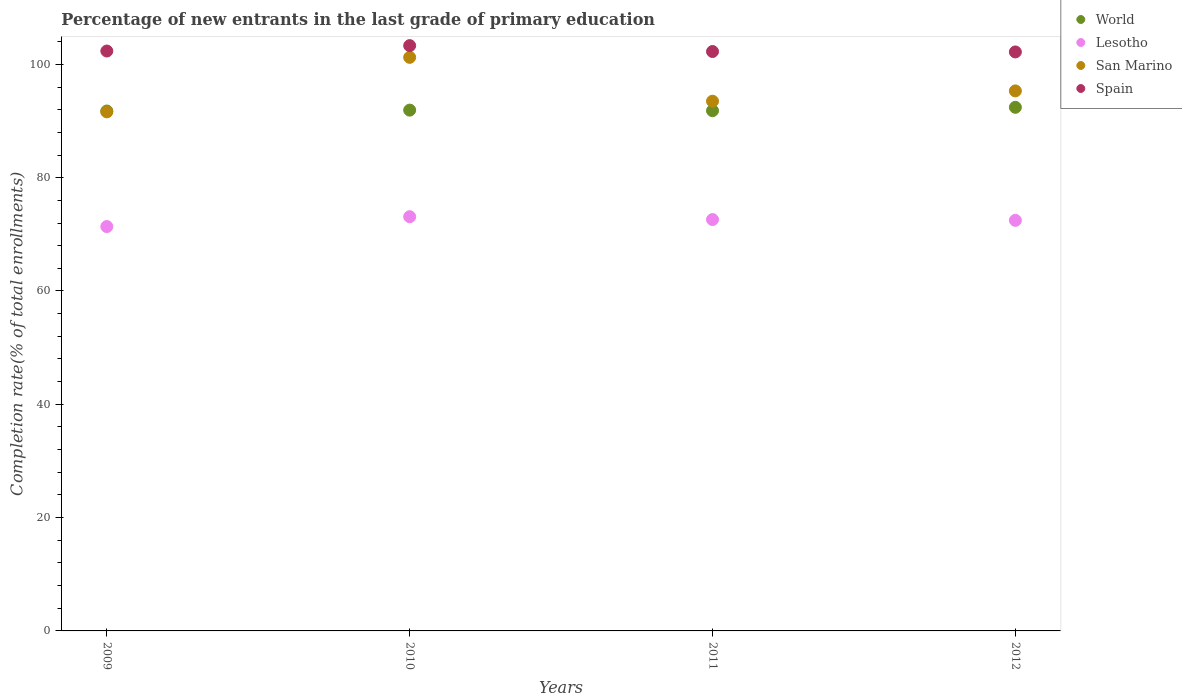Is the number of dotlines equal to the number of legend labels?
Offer a terse response. Yes. What is the percentage of new entrants in Spain in 2009?
Give a very brief answer. 102.36. Across all years, what is the maximum percentage of new entrants in World?
Offer a terse response. 92.42. Across all years, what is the minimum percentage of new entrants in Spain?
Your answer should be compact. 102.19. In which year was the percentage of new entrants in Lesotho minimum?
Make the answer very short. 2009. What is the total percentage of new entrants in Spain in the graph?
Give a very brief answer. 410.13. What is the difference between the percentage of new entrants in World in 2010 and that in 2011?
Your response must be concise. 0.1. What is the difference between the percentage of new entrants in Spain in 2012 and the percentage of new entrants in San Marino in 2009?
Offer a terse response. 10.58. What is the average percentage of new entrants in San Marino per year?
Give a very brief answer. 95.42. In the year 2011, what is the difference between the percentage of new entrants in San Marino and percentage of new entrants in World?
Keep it short and to the point. 1.67. What is the ratio of the percentage of new entrants in World in 2011 to that in 2012?
Make the answer very short. 0.99. What is the difference between the highest and the second highest percentage of new entrants in Spain?
Offer a terse response. 0.95. What is the difference between the highest and the lowest percentage of new entrants in Lesotho?
Offer a terse response. 1.74. Is the percentage of new entrants in Spain strictly greater than the percentage of new entrants in San Marino over the years?
Your response must be concise. Yes. Is the percentage of new entrants in World strictly less than the percentage of new entrants in Spain over the years?
Make the answer very short. Yes. Are the values on the major ticks of Y-axis written in scientific E-notation?
Offer a very short reply. No. Where does the legend appear in the graph?
Your answer should be compact. Top right. How many legend labels are there?
Give a very brief answer. 4. How are the legend labels stacked?
Provide a succinct answer. Vertical. What is the title of the graph?
Your answer should be very brief. Percentage of new entrants in the last grade of primary education. Does "Cameroon" appear as one of the legend labels in the graph?
Provide a succinct answer. No. What is the label or title of the X-axis?
Offer a very short reply. Years. What is the label or title of the Y-axis?
Your response must be concise. Completion rate(% of total enrollments). What is the Completion rate(% of total enrollments) of World in 2009?
Provide a short and direct response. 91.77. What is the Completion rate(% of total enrollments) of Lesotho in 2009?
Your answer should be compact. 71.37. What is the Completion rate(% of total enrollments) in San Marino in 2009?
Give a very brief answer. 91.62. What is the Completion rate(% of total enrollments) in Spain in 2009?
Offer a terse response. 102.36. What is the Completion rate(% of total enrollments) of World in 2010?
Keep it short and to the point. 91.92. What is the Completion rate(% of total enrollments) in Lesotho in 2010?
Offer a terse response. 73.11. What is the Completion rate(% of total enrollments) of San Marino in 2010?
Ensure brevity in your answer.  101.24. What is the Completion rate(% of total enrollments) in Spain in 2010?
Offer a terse response. 103.31. What is the Completion rate(% of total enrollments) in World in 2011?
Ensure brevity in your answer.  91.83. What is the Completion rate(% of total enrollments) of Lesotho in 2011?
Provide a succinct answer. 72.61. What is the Completion rate(% of total enrollments) in San Marino in 2011?
Make the answer very short. 93.5. What is the Completion rate(% of total enrollments) in Spain in 2011?
Ensure brevity in your answer.  102.27. What is the Completion rate(% of total enrollments) in World in 2012?
Offer a very short reply. 92.42. What is the Completion rate(% of total enrollments) in Lesotho in 2012?
Your response must be concise. 72.47. What is the Completion rate(% of total enrollments) of San Marino in 2012?
Ensure brevity in your answer.  95.32. What is the Completion rate(% of total enrollments) of Spain in 2012?
Your answer should be compact. 102.19. Across all years, what is the maximum Completion rate(% of total enrollments) in World?
Provide a short and direct response. 92.42. Across all years, what is the maximum Completion rate(% of total enrollments) in Lesotho?
Make the answer very short. 73.11. Across all years, what is the maximum Completion rate(% of total enrollments) of San Marino?
Your response must be concise. 101.24. Across all years, what is the maximum Completion rate(% of total enrollments) of Spain?
Make the answer very short. 103.31. Across all years, what is the minimum Completion rate(% of total enrollments) of World?
Provide a succinct answer. 91.77. Across all years, what is the minimum Completion rate(% of total enrollments) in Lesotho?
Your answer should be compact. 71.37. Across all years, what is the minimum Completion rate(% of total enrollments) of San Marino?
Keep it short and to the point. 91.62. Across all years, what is the minimum Completion rate(% of total enrollments) of Spain?
Provide a succinct answer. 102.19. What is the total Completion rate(% of total enrollments) in World in the graph?
Make the answer very short. 367.94. What is the total Completion rate(% of total enrollments) of Lesotho in the graph?
Offer a terse response. 289.56. What is the total Completion rate(% of total enrollments) of San Marino in the graph?
Give a very brief answer. 381.67. What is the total Completion rate(% of total enrollments) of Spain in the graph?
Your answer should be compact. 410.13. What is the difference between the Completion rate(% of total enrollments) in World in 2009 and that in 2010?
Offer a terse response. -0.16. What is the difference between the Completion rate(% of total enrollments) of Lesotho in 2009 and that in 2010?
Ensure brevity in your answer.  -1.74. What is the difference between the Completion rate(% of total enrollments) of San Marino in 2009 and that in 2010?
Your answer should be compact. -9.62. What is the difference between the Completion rate(% of total enrollments) in Spain in 2009 and that in 2010?
Ensure brevity in your answer.  -0.95. What is the difference between the Completion rate(% of total enrollments) of World in 2009 and that in 2011?
Make the answer very short. -0.06. What is the difference between the Completion rate(% of total enrollments) in Lesotho in 2009 and that in 2011?
Offer a terse response. -1.24. What is the difference between the Completion rate(% of total enrollments) in San Marino in 2009 and that in 2011?
Keep it short and to the point. -1.88. What is the difference between the Completion rate(% of total enrollments) in Spain in 2009 and that in 2011?
Your answer should be very brief. 0.09. What is the difference between the Completion rate(% of total enrollments) in World in 2009 and that in 2012?
Ensure brevity in your answer.  -0.65. What is the difference between the Completion rate(% of total enrollments) of Lesotho in 2009 and that in 2012?
Provide a succinct answer. -1.1. What is the difference between the Completion rate(% of total enrollments) in Spain in 2009 and that in 2012?
Give a very brief answer. 0.16. What is the difference between the Completion rate(% of total enrollments) of World in 2010 and that in 2011?
Offer a very short reply. 0.1. What is the difference between the Completion rate(% of total enrollments) in Lesotho in 2010 and that in 2011?
Provide a short and direct response. 0.5. What is the difference between the Completion rate(% of total enrollments) in San Marino in 2010 and that in 2011?
Offer a terse response. 7.74. What is the difference between the Completion rate(% of total enrollments) of Spain in 2010 and that in 2011?
Your answer should be very brief. 1.04. What is the difference between the Completion rate(% of total enrollments) of World in 2010 and that in 2012?
Offer a very short reply. -0.5. What is the difference between the Completion rate(% of total enrollments) in Lesotho in 2010 and that in 2012?
Your response must be concise. 0.65. What is the difference between the Completion rate(% of total enrollments) of San Marino in 2010 and that in 2012?
Your response must be concise. 5.92. What is the difference between the Completion rate(% of total enrollments) in Spain in 2010 and that in 2012?
Offer a terse response. 1.12. What is the difference between the Completion rate(% of total enrollments) of World in 2011 and that in 2012?
Provide a succinct answer. -0.6. What is the difference between the Completion rate(% of total enrollments) in Lesotho in 2011 and that in 2012?
Offer a very short reply. 0.14. What is the difference between the Completion rate(% of total enrollments) in San Marino in 2011 and that in 2012?
Provide a succinct answer. -1.82. What is the difference between the Completion rate(% of total enrollments) in Spain in 2011 and that in 2012?
Your answer should be very brief. 0.07. What is the difference between the Completion rate(% of total enrollments) in World in 2009 and the Completion rate(% of total enrollments) in Lesotho in 2010?
Your answer should be very brief. 18.65. What is the difference between the Completion rate(% of total enrollments) in World in 2009 and the Completion rate(% of total enrollments) in San Marino in 2010?
Offer a terse response. -9.47. What is the difference between the Completion rate(% of total enrollments) in World in 2009 and the Completion rate(% of total enrollments) in Spain in 2010?
Your answer should be very brief. -11.54. What is the difference between the Completion rate(% of total enrollments) of Lesotho in 2009 and the Completion rate(% of total enrollments) of San Marino in 2010?
Keep it short and to the point. -29.87. What is the difference between the Completion rate(% of total enrollments) of Lesotho in 2009 and the Completion rate(% of total enrollments) of Spain in 2010?
Offer a terse response. -31.94. What is the difference between the Completion rate(% of total enrollments) of San Marino in 2009 and the Completion rate(% of total enrollments) of Spain in 2010?
Your answer should be very brief. -11.69. What is the difference between the Completion rate(% of total enrollments) of World in 2009 and the Completion rate(% of total enrollments) of Lesotho in 2011?
Ensure brevity in your answer.  19.16. What is the difference between the Completion rate(% of total enrollments) in World in 2009 and the Completion rate(% of total enrollments) in San Marino in 2011?
Your answer should be very brief. -1.73. What is the difference between the Completion rate(% of total enrollments) of World in 2009 and the Completion rate(% of total enrollments) of Spain in 2011?
Give a very brief answer. -10.5. What is the difference between the Completion rate(% of total enrollments) in Lesotho in 2009 and the Completion rate(% of total enrollments) in San Marino in 2011?
Keep it short and to the point. -22.13. What is the difference between the Completion rate(% of total enrollments) of Lesotho in 2009 and the Completion rate(% of total enrollments) of Spain in 2011?
Provide a succinct answer. -30.9. What is the difference between the Completion rate(% of total enrollments) of San Marino in 2009 and the Completion rate(% of total enrollments) of Spain in 2011?
Offer a terse response. -10.65. What is the difference between the Completion rate(% of total enrollments) of World in 2009 and the Completion rate(% of total enrollments) of Lesotho in 2012?
Make the answer very short. 19.3. What is the difference between the Completion rate(% of total enrollments) of World in 2009 and the Completion rate(% of total enrollments) of San Marino in 2012?
Provide a short and direct response. -3.55. What is the difference between the Completion rate(% of total enrollments) of World in 2009 and the Completion rate(% of total enrollments) of Spain in 2012?
Offer a terse response. -10.43. What is the difference between the Completion rate(% of total enrollments) of Lesotho in 2009 and the Completion rate(% of total enrollments) of San Marino in 2012?
Offer a terse response. -23.94. What is the difference between the Completion rate(% of total enrollments) of Lesotho in 2009 and the Completion rate(% of total enrollments) of Spain in 2012?
Give a very brief answer. -30.82. What is the difference between the Completion rate(% of total enrollments) in San Marino in 2009 and the Completion rate(% of total enrollments) in Spain in 2012?
Offer a terse response. -10.58. What is the difference between the Completion rate(% of total enrollments) in World in 2010 and the Completion rate(% of total enrollments) in Lesotho in 2011?
Make the answer very short. 19.31. What is the difference between the Completion rate(% of total enrollments) of World in 2010 and the Completion rate(% of total enrollments) of San Marino in 2011?
Keep it short and to the point. -1.58. What is the difference between the Completion rate(% of total enrollments) in World in 2010 and the Completion rate(% of total enrollments) in Spain in 2011?
Provide a succinct answer. -10.35. What is the difference between the Completion rate(% of total enrollments) of Lesotho in 2010 and the Completion rate(% of total enrollments) of San Marino in 2011?
Provide a short and direct response. -20.38. What is the difference between the Completion rate(% of total enrollments) of Lesotho in 2010 and the Completion rate(% of total enrollments) of Spain in 2011?
Your answer should be compact. -29.16. What is the difference between the Completion rate(% of total enrollments) of San Marino in 2010 and the Completion rate(% of total enrollments) of Spain in 2011?
Give a very brief answer. -1.03. What is the difference between the Completion rate(% of total enrollments) of World in 2010 and the Completion rate(% of total enrollments) of Lesotho in 2012?
Make the answer very short. 19.45. What is the difference between the Completion rate(% of total enrollments) in World in 2010 and the Completion rate(% of total enrollments) in San Marino in 2012?
Keep it short and to the point. -3.39. What is the difference between the Completion rate(% of total enrollments) in World in 2010 and the Completion rate(% of total enrollments) in Spain in 2012?
Provide a short and direct response. -10.27. What is the difference between the Completion rate(% of total enrollments) of Lesotho in 2010 and the Completion rate(% of total enrollments) of San Marino in 2012?
Provide a succinct answer. -22.2. What is the difference between the Completion rate(% of total enrollments) in Lesotho in 2010 and the Completion rate(% of total enrollments) in Spain in 2012?
Ensure brevity in your answer.  -29.08. What is the difference between the Completion rate(% of total enrollments) in San Marino in 2010 and the Completion rate(% of total enrollments) in Spain in 2012?
Give a very brief answer. -0.96. What is the difference between the Completion rate(% of total enrollments) in World in 2011 and the Completion rate(% of total enrollments) in Lesotho in 2012?
Provide a short and direct response. 19.36. What is the difference between the Completion rate(% of total enrollments) of World in 2011 and the Completion rate(% of total enrollments) of San Marino in 2012?
Provide a succinct answer. -3.49. What is the difference between the Completion rate(% of total enrollments) of World in 2011 and the Completion rate(% of total enrollments) of Spain in 2012?
Ensure brevity in your answer.  -10.37. What is the difference between the Completion rate(% of total enrollments) of Lesotho in 2011 and the Completion rate(% of total enrollments) of San Marino in 2012?
Keep it short and to the point. -22.71. What is the difference between the Completion rate(% of total enrollments) in Lesotho in 2011 and the Completion rate(% of total enrollments) in Spain in 2012?
Your response must be concise. -29.59. What is the difference between the Completion rate(% of total enrollments) of San Marino in 2011 and the Completion rate(% of total enrollments) of Spain in 2012?
Ensure brevity in your answer.  -8.7. What is the average Completion rate(% of total enrollments) in World per year?
Provide a short and direct response. 91.98. What is the average Completion rate(% of total enrollments) of Lesotho per year?
Provide a succinct answer. 72.39. What is the average Completion rate(% of total enrollments) of San Marino per year?
Your response must be concise. 95.42. What is the average Completion rate(% of total enrollments) in Spain per year?
Your answer should be compact. 102.53. In the year 2009, what is the difference between the Completion rate(% of total enrollments) of World and Completion rate(% of total enrollments) of Lesotho?
Ensure brevity in your answer.  20.39. In the year 2009, what is the difference between the Completion rate(% of total enrollments) of World and Completion rate(% of total enrollments) of San Marino?
Offer a terse response. 0.15. In the year 2009, what is the difference between the Completion rate(% of total enrollments) of World and Completion rate(% of total enrollments) of Spain?
Your response must be concise. -10.59. In the year 2009, what is the difference between the Completion rate(% of total enrollments) of Lesotho and Completion rate(% of total enrollments) of San Marino?
Your answer should be compact. -20.24. In the year 2009, what is the difference between the Completion rate(% of total enrollments) of Lesotho and Completion rate(% of total enrollments) of Spain?
Make the answer very short. -30.98. In the year 2009, what is the difference between the Completion rate(% of total enrollments) in San Marino and Completion rate(% of total enrollments) in Spain?
Offer a terse response. -10.74. In the year 2010, what is the difference between the Completion rate(% of total enrollments) of World and Completion rate(% of total enrollments) of Lesotho?
Provide a succinct answer. 18.81. In the year 2010, what is the difference between the Completion rate(% of total enrollments) of World and Completion rate(% of total enrollments) of San Marino?
Your response must be concise. -9.32. In the year 2010, what is the difference between the Completion rate(% of total enrollments) of World and Completion rate(% of total enrollments) of Spain?
Offer a very short reply. -11.39. In the year 2010, what is the difference between the Completion rate(% of total enrollments) of Lesotho and Completion rate(% of total enrollments) of San Marino?
Offer a very short reply. -28.12. In the year 2010, what is the difference between the Completion rate(% of total enrollments) in Lesotho and Completion rate(% of total enrollments) in Spain?
Make the answer very short. -30.2. In the year 2010, what is the difference between the Completion rate(% of total enrollments) in San Marino and Completion rate(% of total enrollments) in Spain?
Give a very brief answer. -2.07. In the year 2011, what is the difference between the Completion rate(% of total enrollments) of World and Completion rate(% of total enrollments) of Lesotho?
Keep it short and to the point. 19.22. In the year 2011, what is the difference between the Completion rate(% of total enrollments) of World and Completion rate(% of total enrollments) of San Marino?
Make the answer very short. -1.67. In the year 2011, what is the difference between the Completion rate(% of total enrollments) in World and Completion rate(% of total enrollments) in Spain?
Offer a terse response. -10.44. In the year 2011, what is the difference between the Completion rate(% of total enrollments) in Lesotho and Completion rate(% of total enrollments) in San Marino?
Make the answer very short. -20.89. In the year 2011, what is the difference between the Completion rate(% of total enrollments) of Lesotho and Completion rate(% of total enrollments) of Spain?
Make the answer very short. -29.66. In the year 2011, what is the difference between the Completion rate(% of total enrollments) of San Marino and Completion rate(% of total enrollments) of Spain?
Provide a short and direct response. -8.77. In the year 2012, what is the difference between the Completion rate(% of total enrollments) in World and Completion rate(% of total enrollments) in Lesotho?
Your answer should be very brief. 19.95. In the year 2012, what is the difference between the Completion rate(% of total enrollments) in World and Completion rate(% of total enrollments) in San Marino?
Ensure brevity in your answer.  -2.9. In the year 2012, what is the difference between the Completion rate(% of total enrollments) of World and Completion rate(% of total enrollments) of Spain?
Offer a terse response. -9.77. In the year 2012, what is the difference between the Completion rate(% of total enrollments) of Lesotho and Completion rate(% of total enrollments) of San Marino?
Offer a very short reply. -22.85. In the year 2012, what is the difference between the Completion rate(% of total enrollments) of Lesotho and Completion rate(% of total enrollments) of Spain?
Give a very brief answer. -29.73. In the year 2012, what is the difference between the Completion rate(% of total enrollments) in San Marino and Completion rate(% of total enrollments) in Spain?
Ensure brevity in your answer.  -6.88. What is the ratio of the Completion rate(% of total enrollments) of Lesotho in 2009 to that in 2010?
Ensure brevity in your answer.  0.98. What is the ratio of the Completion rate(% of total enrollments) in San Marino in 2009 to that in 2010?
Ensure brevity in your answer.  0.91. What is the ratio of the Completion rate(% of total enrollments) of World in 2009 to that in 2011?
Provide a succinct answer. 1. What is the ratio of the Completion rate(% of total enrollments) of Lesotho in 2009 to that in 2011?
Keep it short and to the point. 0.98. What is the ratio of the Completion rate(% of total enrollments) in San Marino in 2009 to that in 2011?
Give a very brief answer. 0.98. What is the ratio of the Completion rate(% of total enrollments) in World in 2009 to that in 2012?
Provide a succinct answer. 0.99. What is the ratio of the Completion rate(% of total enrollments) in Lesotho in 2009 to that in 2012?
Provide a succinct answer. 0.98. What is the ratio of the Completion rate(% of total enrollments) in San Marino in 2009 to that in 2012?
Your answer should be very brief. 0.96. What is the ratio of the Completion rate(% of total enrollments) of Spain in 2009 to that in 2012?
Provide a succinct answer. 1. What is the ratio of the Completion rate(% of total enrollments) in World in 2010 to that in 2011?
Offer a very short reply. 1. What is the ratio of the Completion rate(% of total enrollments) in Lesotho in 2010 to that in 2011?
Your answer should be compact. 1.01. What is the ratio of the Completion rate(% of total enrollments) in San Marino in 2010 to that in 2011?
Provide a short and direct response. 1.08. What is the ratio of the Completion rate(% of total enrollments) of Spain in 2010 to that in 2011?
Your response must be concise. 1.01. What is the ratio of the Completion rate(% of total enrollments) of World in 2010 to that in 2012?
Ensure brevity in your answer.  0.99. What is the ratio of the Completion rate(% of total enrollments) in Lesotho in 2010 to that in 2012?
Keep it short and to the point. 1.01. What is the ratio of the Completion rate(% of total enrollments) in San Marino in 2010 to that in 2012?
Your answer should be very brief. 1.06. What is the ratio of the Completion rate(% of total enrollments) in Spain in 2010 to that in 2012?
Your answer should be very brief. 1.01. What is the ratio of the Completion rate(% of total enrollments) of Lesotho in 2011 to that in 2012?
Ensure brevity in your answer.  1. What is the ratio of the Completion rate(% of total enrollments) in San Marino in 2011 to that in 2012?
Your answer should be very brief. 0.98. What is the ratio of the Completion rate(% of total enrollments) of Spain in 2011 to that in 2012?
Give a very brief answer. 1. What is the difference between the highest and the second highest Completion rate(% of total enrollments) of World?
Provide a short and direct response. 0.5. What is the difference between the highest and the second highest Completion rate(% of total enrollments) of Lesotho?
Your answer should be compact. 0.5. What is the difference between the highest and the second highest Completion rate(% of total enrollments) of San Marino?
Ensure brevity in your answer.  5.92. What is the difference between the highest and the second highest Completion rate(% of total enrollments) in Spain?
Make the answer very short. 0.95. What is the difference between the highest and the lowest Completion rate(% of total enrollments) in World?
Your response must be concise. 0.65. What is the difference between the highest and the lowest Completion rate(% of total enrollments) in Lesotho?
Your answer should be compact. 1.74. What is the difference between the highest and the lowest Completion rate(% of total enrollments) in San Marino?
Give a very brief answer. 9.62. What is the difference between the highest and the lowest Completion rate(% of total enrollments) of Spain?
Provide a succinct answer. 1.12. 